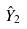Convert formula to latex. <formula><loc_0><loc_0><loc_500><loc_500>\hat { Y } _ { 2 }</formula> 